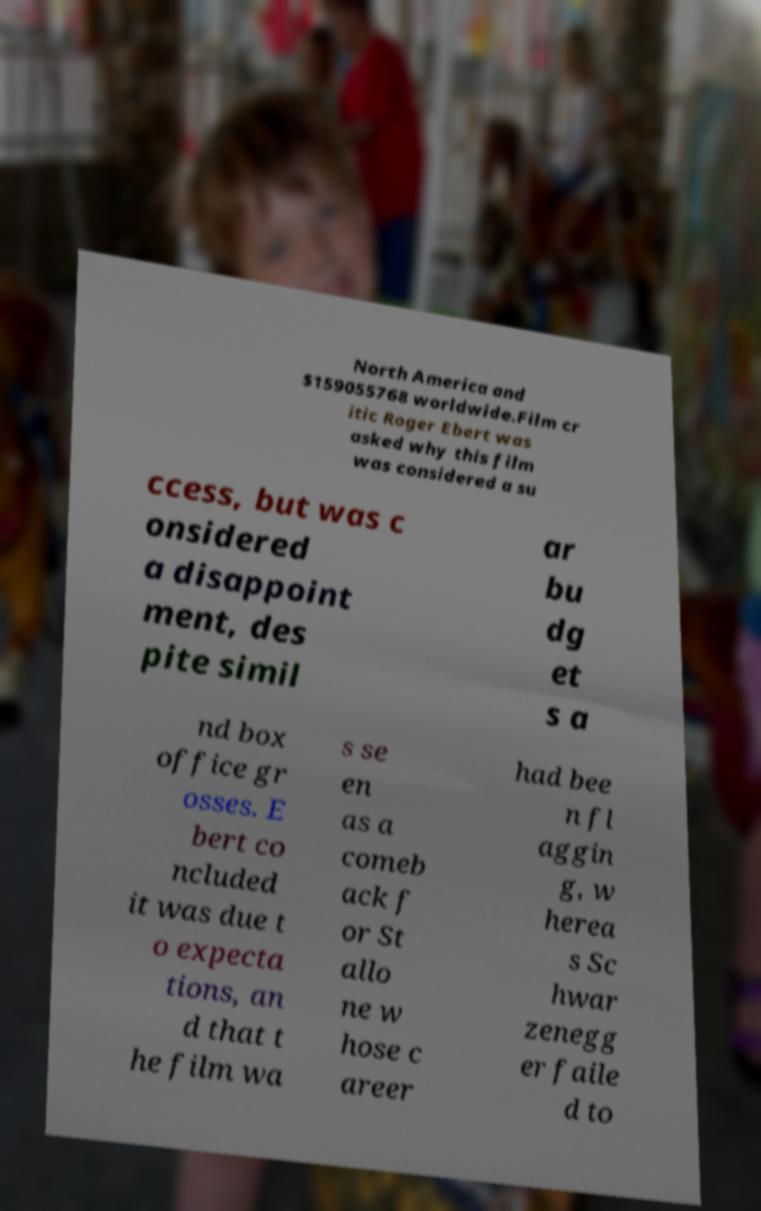What messages or text are displayed in this image? I need them in a readable, typed format. North America and $159055768 worldwide.Film cr itic Roger Ebert was asked why this film was considered a su ccess, but was c onsidered a disappoint ment, des pite simil ar bu dg et s a nd box office gr osses. E bert co ncluded it was due t o expecta tions, an d that t he film wa s se en as a comeb ack f or St allo ne w hose c areer had bee n fl aggin g, w herea s Sc hwar zenegg er faile d to 